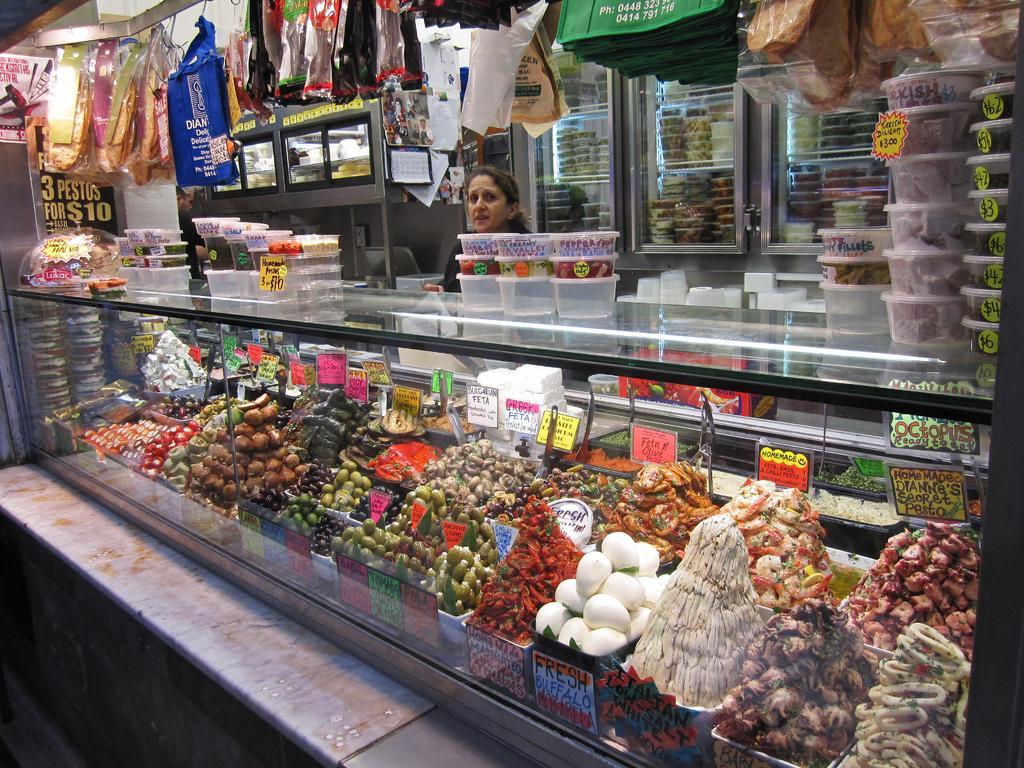Can you describe this image briefly? In this image we can see a stall and there is a glass box with few food items and there are few food items on the box and in the background there are cupboards with food items and few bags hanged to the iron rod. 